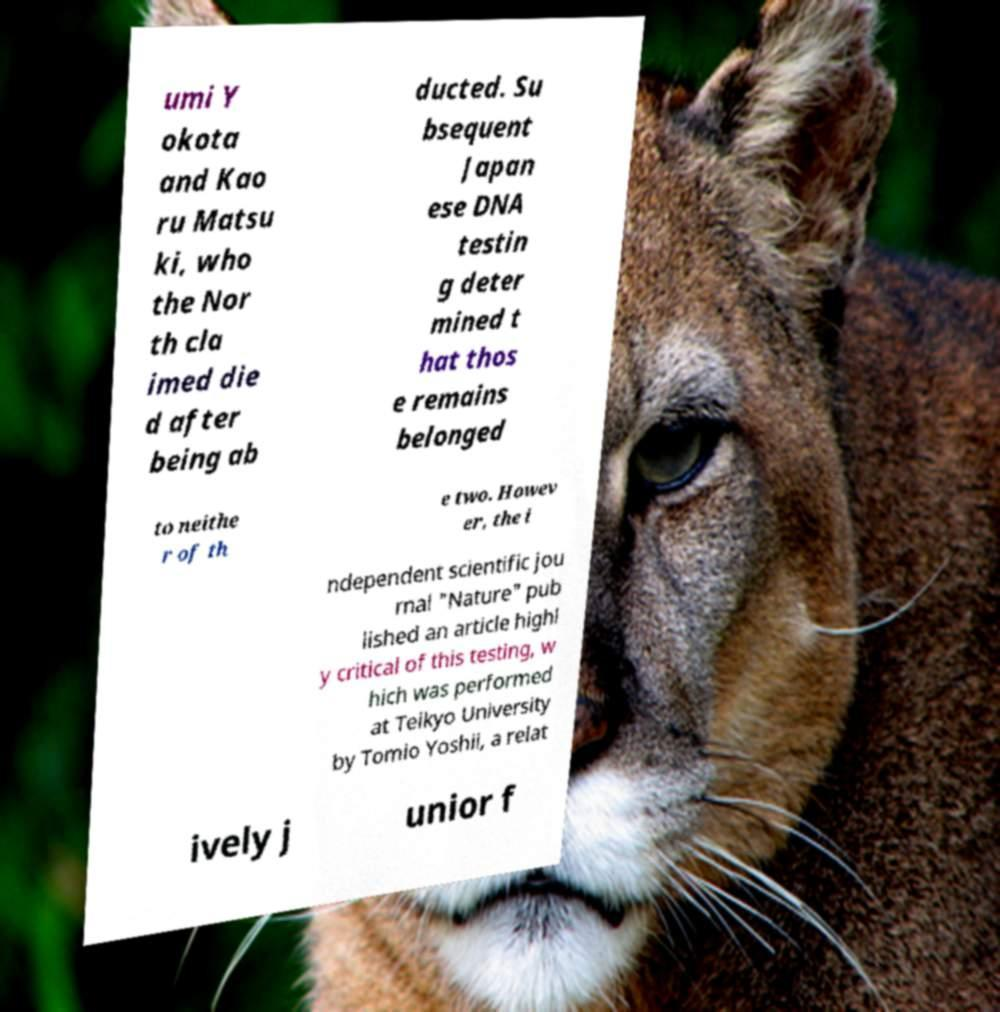I need the written content from this picture converted into text. Can you do that? umi Y okota and Kao ru Matsu ki, who the Nor th cla imed die d after being ab ducted. Su bsequent Japan ese DNA testin g deter mined t hat thos e remains belonged to neithe r of th e two. Howev er, the i ndependent scientific jou rnal "Nature" pub lished an article highl y critical of this testing, w hich was performed at Teikyo University by Tomio Yoshii, a relat ively j unior f 